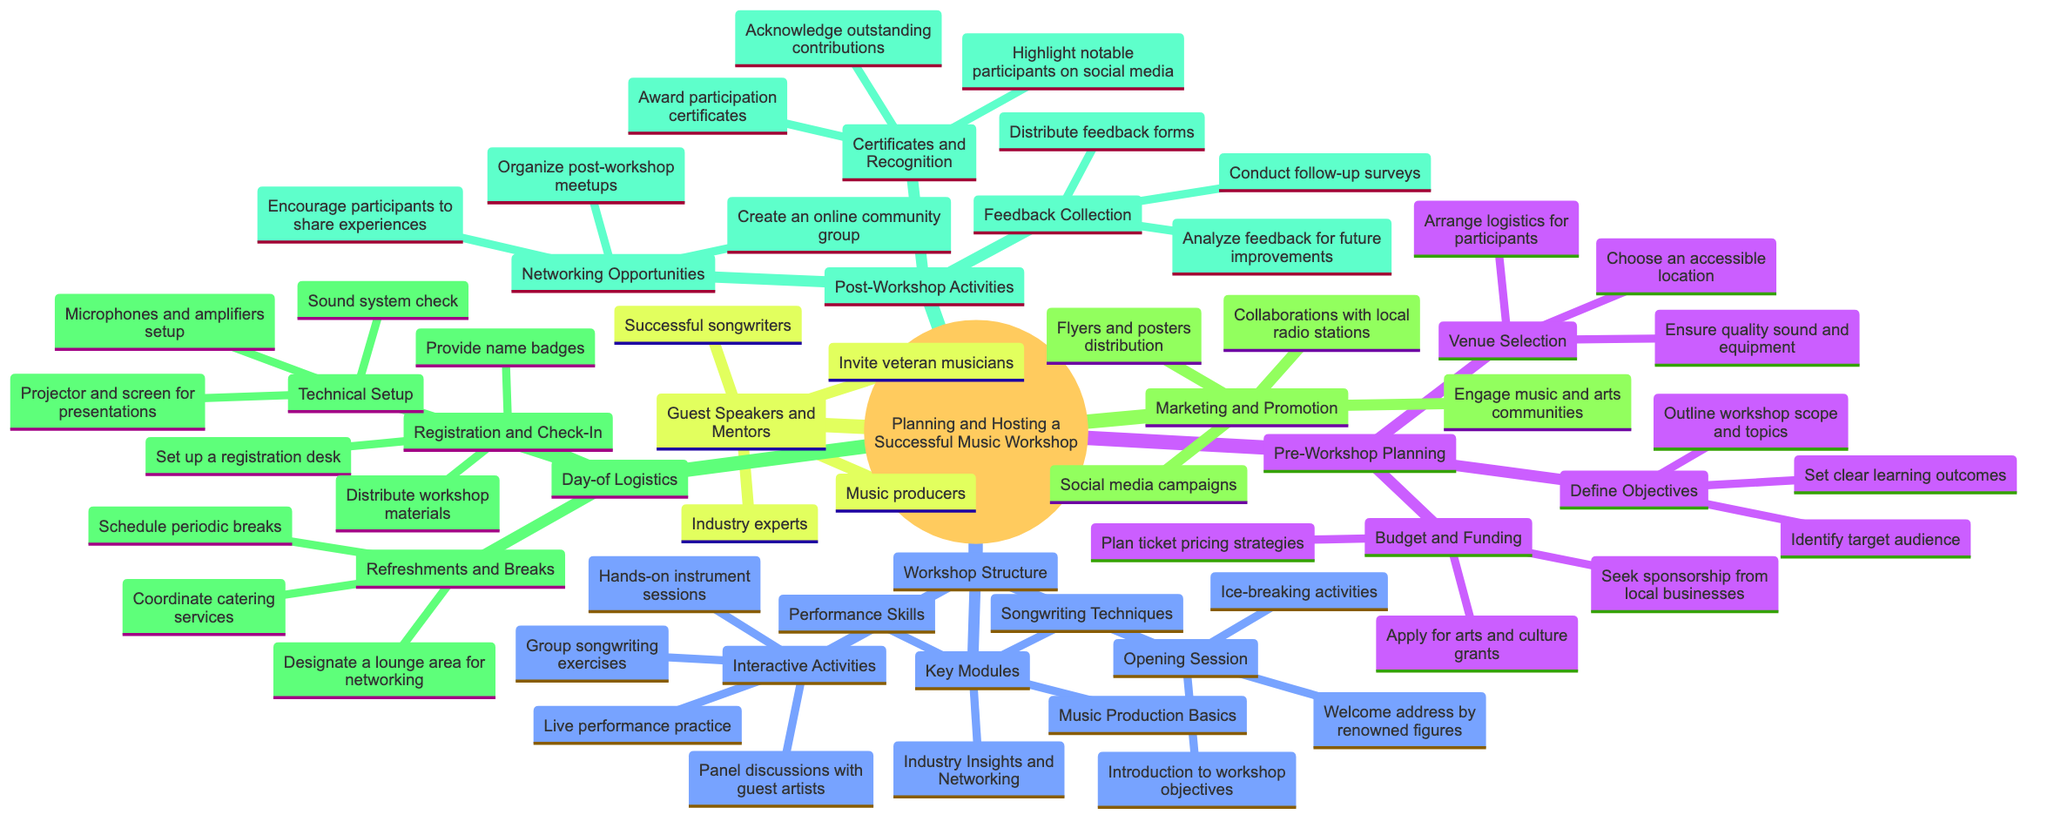What are the three main categories of the workshop plan? The diagram lists "Pre-Workshop Planning," "Workshop Structure," "Guest Speakers and Mentors," "Marketing and Promotion," "Day-of Logistics," and "Post-Workshop Activities" as the main categories. Therefore, one can identify three of these as the primary categories to focus on, without specifying all six.
Answer: Pre-Workshop Planning, Workshop Structure, Post-Workshop Activities How many key modules are listed in the workshop structure? The "Key Modules" section of the diagram contains four distinct items: "Songwriting Techniques," "Music Production Basics," "Performance Skills," and "Industry Insights and Networking," which means the total number is four.
Answer: 4 Which activity is included in both the Opening Session and Interactive Activities? Both sections include activities that engage participants, typically focusing on introductions or teamwork. In the "Opening Session," "Ice-breaking activities" and in "Interactive Activities," group sessions are encouraged. Thus, the overlap aspect could mainly reference the engaging nature.
Answer: Ice-breaking activities What is the purpose of the "Feedback Collection" section? The "Feedback Collection" is primarily about gathering participant reactions and insights about the workshop through various means such as feedback forms and follow-up surveys to evaluate its effectiveness.
Answer: Evaluate workshop effectiveness What are the two aspects covered under Day-of Logistics related to participant management? "Registration and Check-In" and "Technical Setup" relate directly to managing the participants' entry and their experience during the workshop; registration ensures they are accounted for while technical setup ensures they have the proper environment.
Answer: Registration and Check-In, Technical Setup 